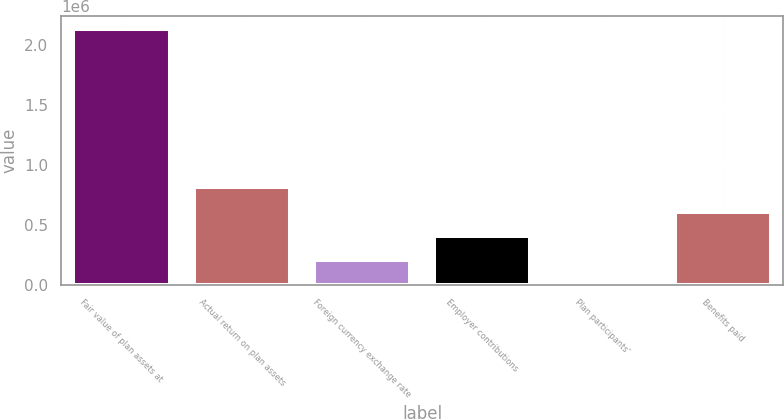Convert chart to OTSL. <chart><loc_0><loc_0><loc_500><loc_500><bar_chart><fcel>Fair value of plan assets at<fcel>Actual return on plan assets<fcel>Foreign currency exchange rate<fcel>Employer contributions<fcel>Plan participants'<fcel>Benefits paid<nl><fcel>2.13489e+06<fcel>810850<fcel>205357<fcel>407188<fcel>3526<fcel>609019<nl></chart> 